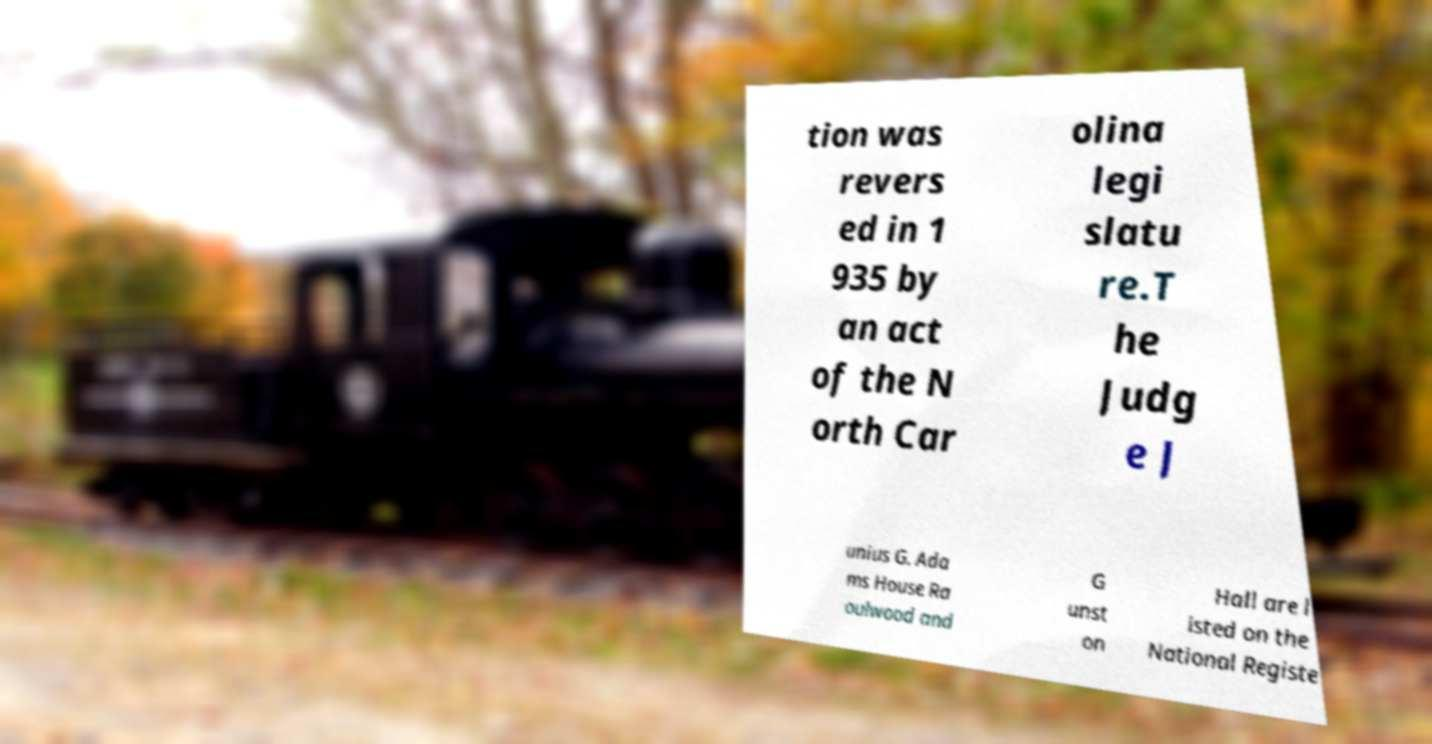There's text embedded in this image that I need extracted. Can you transcribe it verbatim? tion was revers ed in 1 935 by an act of the N orth Car olina legi slatu re.T he Judg e J unius G. Ada ms House Ra oulwood and G unst on Hall are l isted on the National Registe 